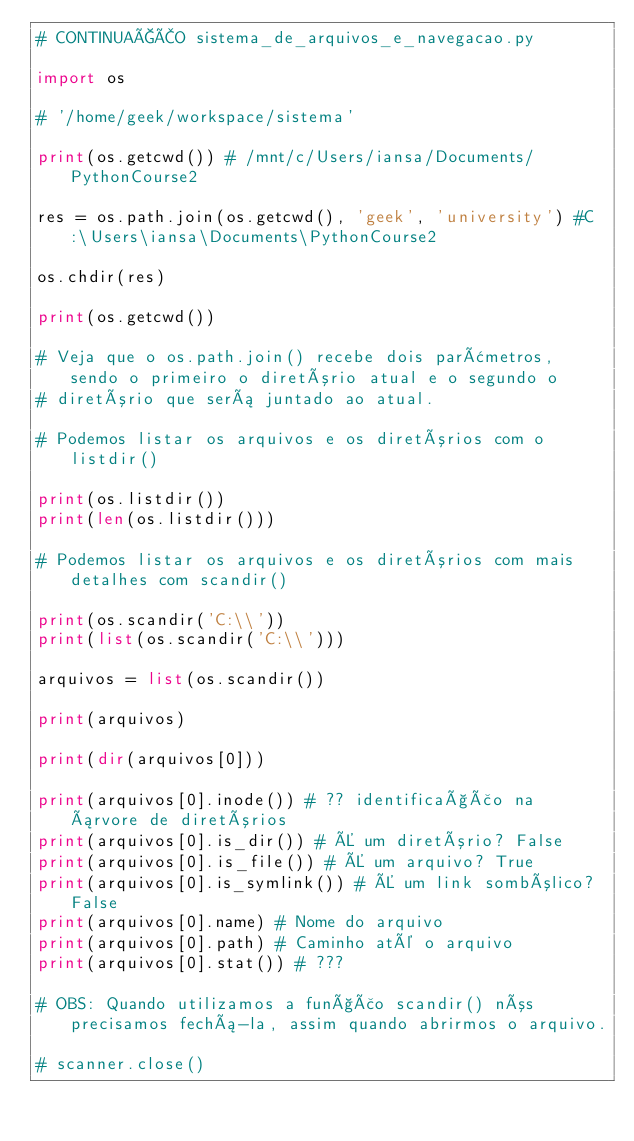Convert code to text. <code><loc_0><loc_0><loc_500><loc_500><_Python_># CONTINUAÇÃO sistema_de_arquivos_e_navegacao.py

import os 

# '/home/geek/workspace/sistema'

print(os.getcwd()) # /mnt/c/Users/iansa/Documents/PythonCourse2

res = os.path.join(os.getcwd(), 'geek', 'university') #C:\Users\iansa\Documents\PythonCourse2

os.chdir(res)

print(os.getcwd())

# Veja que o os.path.join() recebe dois parâmetros, sendo o primeiro o diretório atual e o segundo o 
# diretório que será juntado ao atual. 

# Podemos listar os arquivos e os diretórios com o listdir()

print(os.listdir())
print(len(os.listdir()))

# Podemos listar os arquivos e os diretórios com mais detalhes com scandir()

print(os.scandir('C:\\'))
print(list(os.scandir('C:\\')))

arquivos = list(os.scandir())
 
print(arquivos)

print(dir(arquivos[0]))

print(arquivos[0].inode()) # ?? identificação na árvore de diretórios
print(arquivos[0].is_dir()) # É um diretório? False
print(arquivos[0].is_file()) # É um arquivo? True
print(arquivos[0].is_symlink()) # É um link sombólico? False
print(arquivos[0].name) # Nome do arquivo
print(arquivos[0].path) # Caminho até o arquivo
print(arquivos[0].stat()) # ???

# OBS: Quando utilizamos a função scandir() nós precisamos fechá-la, assim quando abrirmos o arquivo.

# scanner.close() </code> 